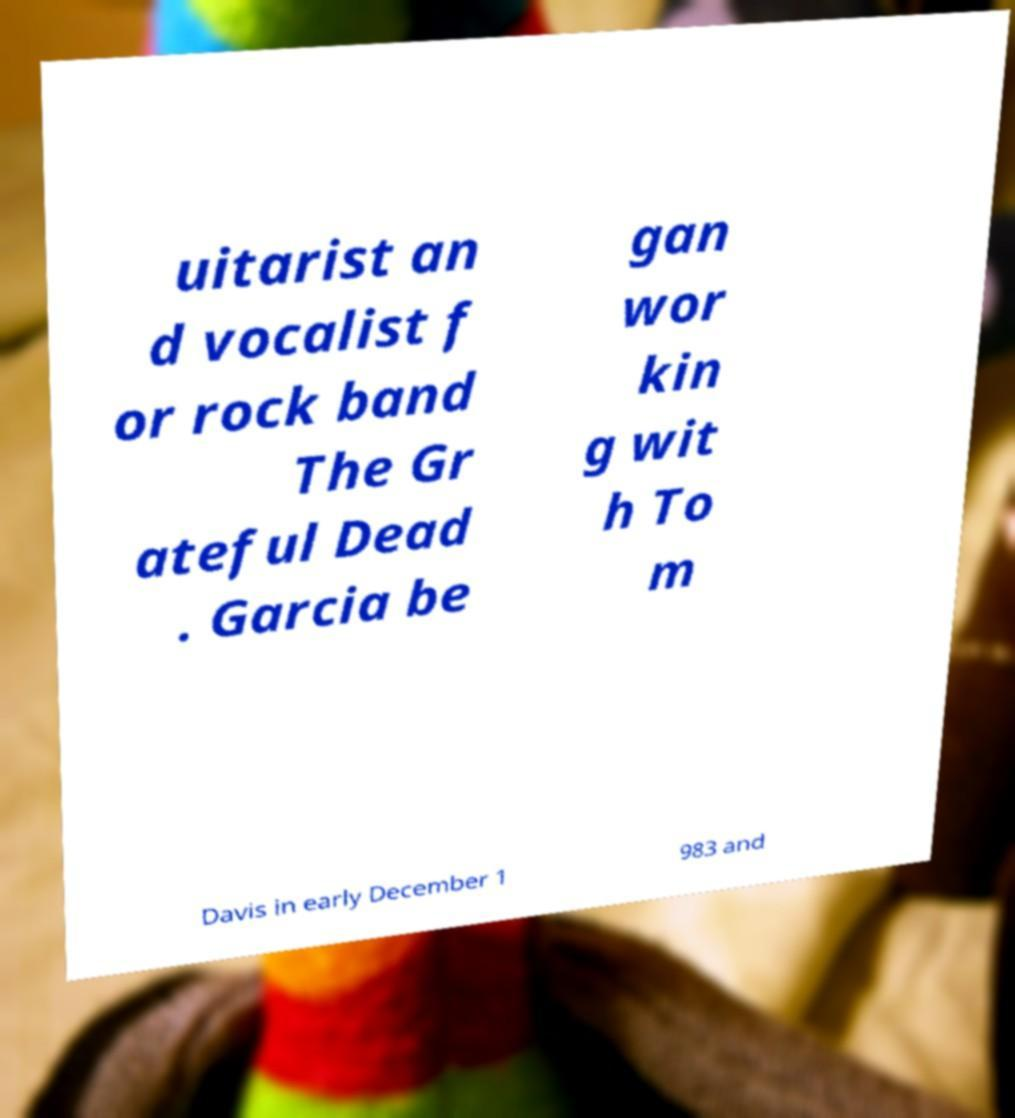Could you extract and type out the text from this image? uitarist an d vocalist f or rock band The Gr ateful Dead . Garcia be gan wor kin g wit h To m Davis in early December 1 983 and 